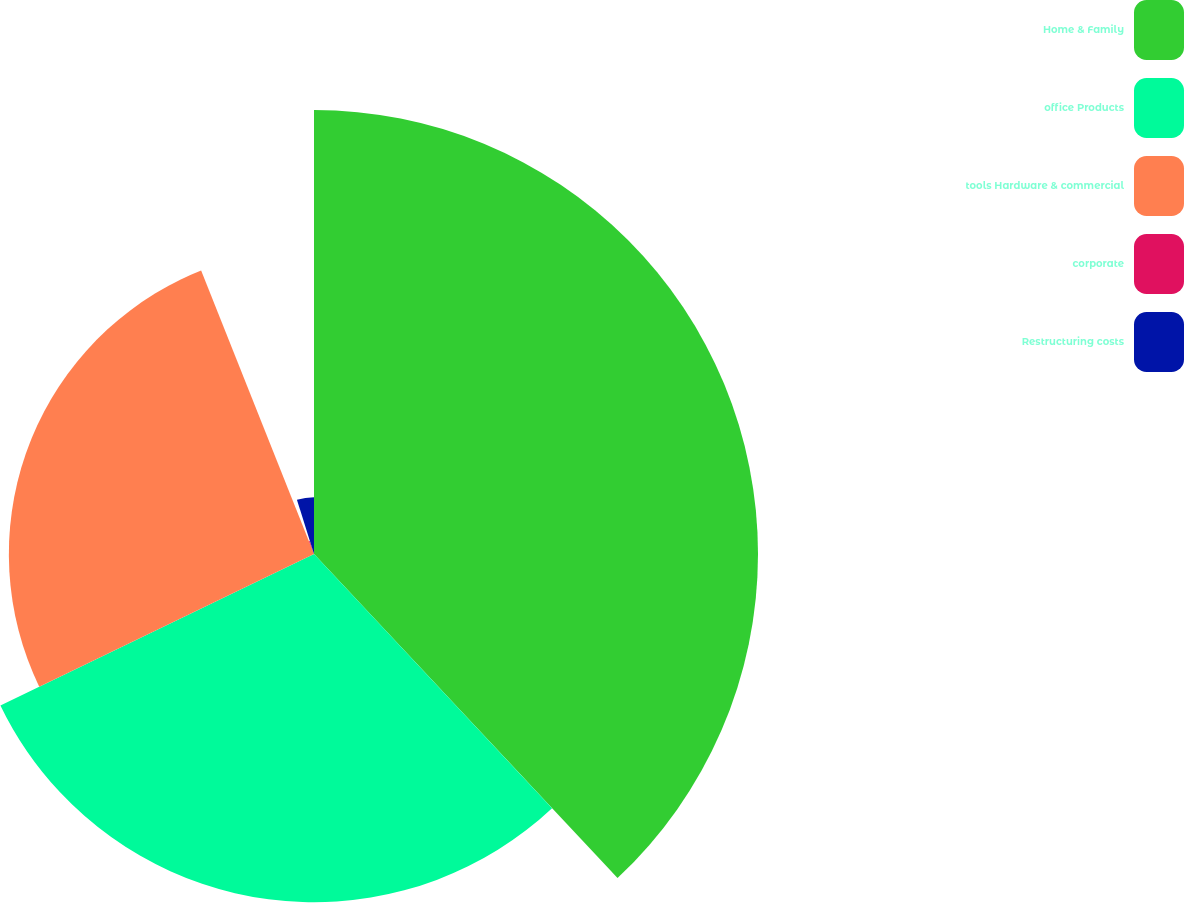Convert chart to OTSL. <chart><loc_0><loc_0><loc_500><loc_500><pie_chart><fcel>Home & Family<fcel>office Products<fcel>tools Hardware & commercial<fcel>corporate<fcel>Restructuring costs<nl><fcel>38.02%<fcel>29.82%<fcel>26.13%<fcel>1.17%<fcel>4.86%<nl></chart> 